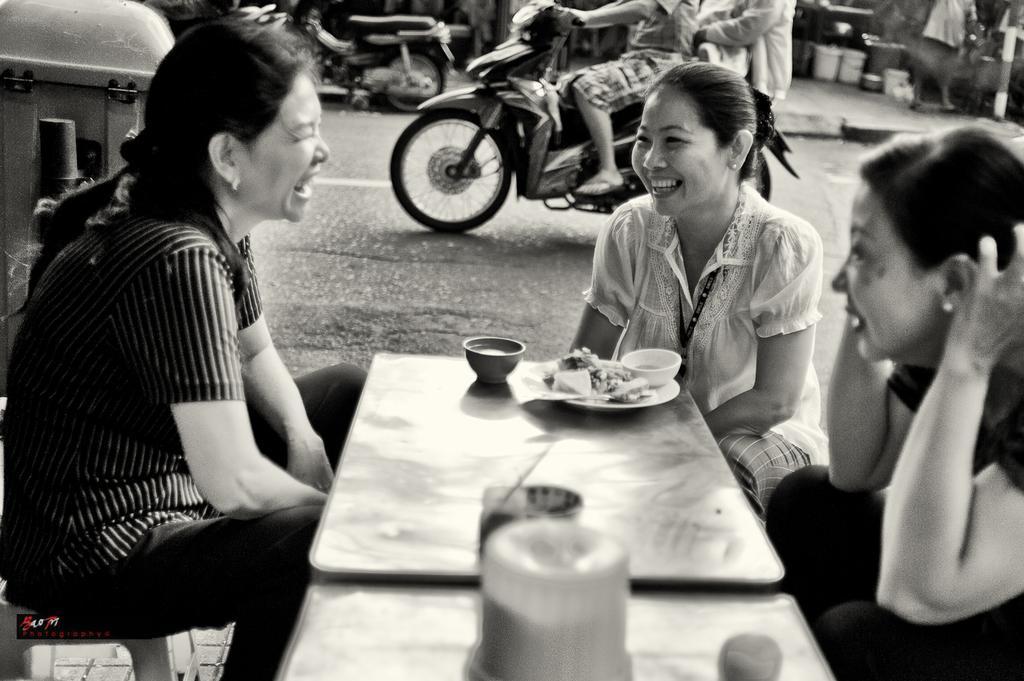In one or two sentences, can you explain what this image depicts? In the picture we can see three women sitting on the stools near the table, on the table we can see a plate with food and bowl in it and the bowl near it, in the background we can see two bikes, on one bike there are two people sitting and riding and we can see some buckets near the table on the path. 